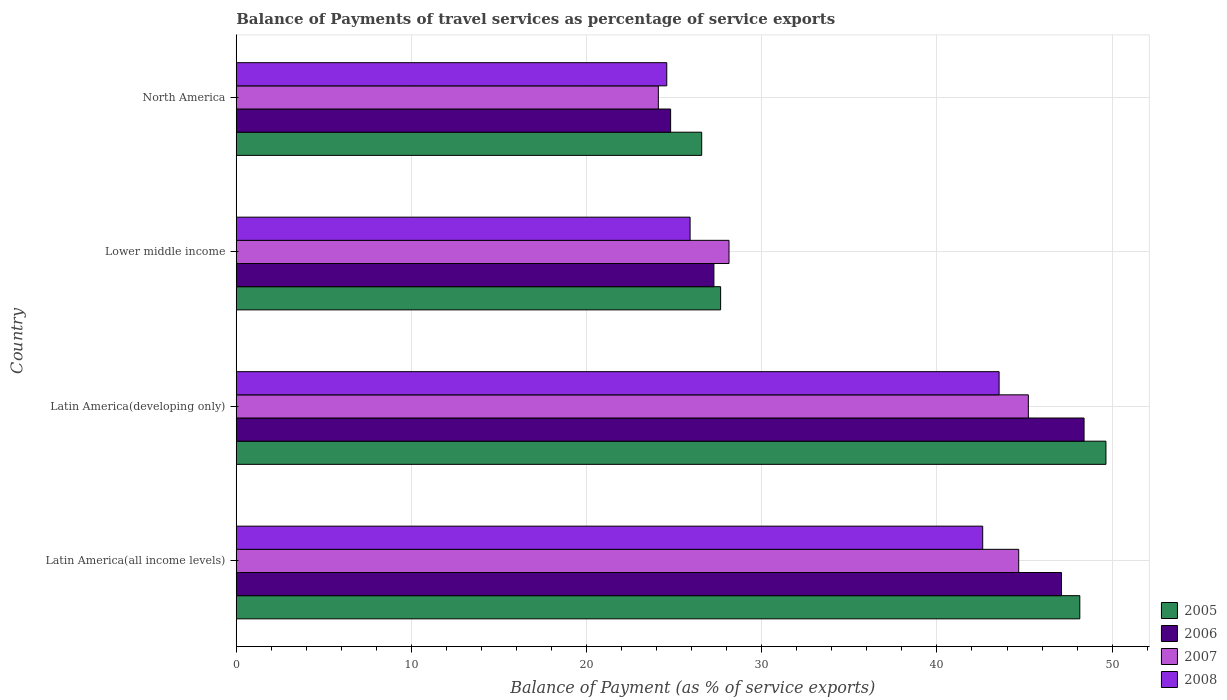How many groups of bars are there?
Offer a very short reply. 4. Are the number of bars per tick equal to the number of legend labels?
Offer a terse response. Yes. Are the number of bars on each tick of the Y-axis equal?
Ensure brevity in your answer.  Yes. How many bars are there on the 3rd tick from the top?
Your answer should be very brief. 4. How many bars are there on the 4th tick from the bottom?
Provide a short and direct response. 4. What is the label of the 3rd group of bars from the top?
Your answer should be compact. Latin America(developing only). In how many cases, is the number of bars for a given country not equal to the number of legend labels?
Ensure brevity in your answer.  0. What is the balance of payments of travel services in 2008 in Lower middle income?
Provide a succinct answer. 25.91. Across all countries, what is the maximum balance of payments of travel services in 2008?
Keep it short and to the point. 43.55. Across all countries, what is the minimum balance of payments of travel services in 2007?
Make the answer very short. 24.1. In which country was the balance of payments of travel services in 2005 maximum?
Offer a terse response. Latin America(developing only). In which country was the balance of payments of travel services in 2008 minimum?
Ensure brevity in your answer.  North America. What is the total balance of payments of travel services in 2007 in the graph?
Provide a short and direct response. 142.11. What is the difference between the balance of payments of travel services in 2007 in Latin America(all income levels) and that in Lower middle income?
Provide a succinct answer. 16.54. What is the difference between the balance of payments of travel services in 2006 in Latin America(all income levels) and the balance of payments of travel services in 2008 in Latin America(developing only)?
Ensure brevity in your answer.  3.56. What is the average balance of payments of travel services in 2005 per country?
Keep it short and to the point. 38.01. What is the difference between the balance of payments of travel services in 2008 and balance of payments of travel services in 2007 in Latin America(developing only)?
Offer a very short reply. -1.67. What is the ratio of the balance of payments of travel services in 2007 in Lower middle income to that in North America?
Offer a terse response. 1.17. Is the balance of payments of travel services in 2008 in Latin America(all income levels) less than that in Lower middle income?
Your answer should be compact. No. Is the difference between the balance of payments of travel services in 2008 in Latin America(all income levels) and North America greater than the difference between the balance of payments of travel services in 2007 in Latin America(all income levels) and North America?
Provide a short and direct response. No. What is the difference between the highest and the second highest balance of payments of travel services in 2007?
Ensure brevity in your answer.  0.55. What is the difference between the highest and the lowest balance of payments of travel services in 2006?
Ensure brevity in your answer.  23.6. Is the sum of the balance of payments of travel services in 2005 in Latin America(developing only) and Lower middle income greater than the maximum balance of payments of travel services in 2006 across all countries?
Ensure brevity in your answer.  Yes. What does the 4th bar from the bottom in Latin America(developing only) represents?
Offer a terse response. 2008. How many bars are there?
Make the answer very short. 16. Are all the bars in the graph horizontal?
Keep it short and to the point. Yes. How many countries are there in the graph?
Your answer should be very brief. 4. Are the values on the major ticks of X-axis written in scientific E-notation?
Provide a short and direct response. No. Does the graph contain grids?
Give a very brief answer. Yes. Where does the legend appear in the graph?
Your answer should be very brief. Bottom right. How many legend labels are there?
Give a very brief answer. 4. What is the title of the graph?
Provide a short and direct response. Balance of Payments of travel services as percentage of service exports. Does "1996" appear as one of the legend labels in the graph?
Ensure brevity in your answer.  No. What is the label or title of the X-axis?
Your answer should be very brief. Balance of Payment (as % of service exports). What is the Balance of Payment (as % of service exports) in 2005 in Latin America(all income levels)?
Provide a short and direct response. 48.16. What is the Balance of Payment (as % of service exports) of 2006 in Latin America(all income levels)?
Offer a terse response. 47.11. What is the Balance of Payment (as % of service exports) in 2007 in Latin America(all income levels)?
Provide a short and direct response. 44.67. What is the Balance of Payment (as % of service exports) of 2008 in Latin America(all income levels)?
Provide a short and direct response. 42.61. What is the Balance of Payment (as % of service exports) in 2005 in Latin America(developing only)?
Ensure brevity in your answer.  49.65. What is the Balance of Payment (as % of service exports) in 2006 in Latin America(developing only)?
Provide a short and direct response. 48.4. What is the Balance of Payment (as % of service exports) of 2007 in Latin America(developing only)?
Give a very brief answer. 45.22. What is the Balance of Payment (as % of service exports) in 2008 in Latin America(developing only)?
Your response must be concise. 43.55. What is the Balance of Payment (as % of service exports) in 2005 in Lower middle income?
Keep it short and to the point. 27.65. What is the Balance of Payment (as % of service exports) in 2006 in Lower middle income?
Your answer should be very brief. 27.27. What is the Balance of Payment (as % of service exports) of 2007 in Lower middle income?
Ensure brevity in your answer.  28.13. What is the Balance of Payment (as % of service exports) in 2008 in Lower middle income?
Your answer should be very brief. 25.91. What is the Balance of Payment (as % of service exports) in 2005 in North America?
Provide a short and direct response. 26.57. What is the Balance of Payment (as % of service exports) of 2006 in North America?
Your answer should be compact. 24.8. What is the Balance of Payment (as % of service exports) in 2007 in North America?
Make the answer very short. 24.1. What is the Balance of Payment (as % of service exports) in 2008 in North America?
Your answer should be compact. 24.58. Across all countries, what is the maximum Balance of Payment (as % of service exports) of 2005?
Keep it short and to the point. 49.65. Across all countries, what is the maximum Balance of Payment (as % of service exports) of 2006?
Give a very brief answer. 48.4. Across all countries, what is the maximum Balance of Payment (as % of service exports) in 2007?
Offer a terse response. 45.22. Across all countries, what is the maximum Balance of Payment (as % of service exports) in 2008?
Make the answer very short. 43.55. Across all countries, what is the minimum Balance of Payment (as % of service exports) of 2005?
Ensure brevity in your answer.  26.57. Across all countries, what is the minimum Balance of Payment (as % of service exports) of 2006?
Provide a short and direct response. 24.8. Across all countries, what is the minimum Balance of Payment (as % of service exports) of 2007?
Provide a short and direct response. 24.1. Across all countries, what is the minimum Balance of Payment (as % of service exports) in 2008?
Your answer should be compact. 24.58. What is the total Balance of Payment (as % of service exports) of 2005 in the graph?
Offer a terse response. 152.02. What is the total Balance of Payment (as % of service exports) in 2006 in the graph?
Your answer should be very brief. 147.57. What is the total Balance of Payment (as % of service exports) in 2007 in the graph?
Give a very brief answer. 142.11. What is the total Balance of Payment (as % of service exports) in 2008 in the graph?
Keep it short and to the point. 136.65. What is the difference between the Balance of Payment (as % of service exports) of 2005 in Latin America(all income levels) and that in Latin America(developing only)?
Keep it short and to the point. -1.49. What is the difference between the Balance of Payment (as % of service exports) of 2006 in Latin America(all income levels) and that in Latin America(developing only)?
Offer a terse response. -1.29. What is the difference between the Balance of Payment (as % of service exports) in 2007 in Latin America(all income levels) and that in Latin America(developing only)?
Your response must be concise. -0.55. What is the difference between the Balance of Payment (as % of service exports) of 2008 in Latin America(all income levels) and that in Latin America(developing only)?
Ensure brevity in your answer.  -0.94. What is the difference between the Balance of Payment (as % of service exports) in 2005 in Latin America(all income levels) and that in Lower middle income?
Offer a very short reply. 20.5. What is the difference between the Balance of Payment (as % of service exports) of 2006 in Latin America(all income levels) and that in Lower middle income?
Keep it short and to the point. 19.84. What is the difference between the Balance of Payment (as % of service exports) of 2007 in Latin America(all income levels) and that in Lower middle income?
Offer a terse response. 16.54. What is the difference between the Balance of Payment (as % of service exports) of 2008 in Latin America(all income levels) and that in Lower middle income?
Give a very brief answer. 16.7. What is the difference between the Balance of Payment (as % of service exports) in 2005 in Latin America(all income levels) and that in North America?
Your response must be concise. 21.59. What is the difference between the Balance of Payment (as % of service exports) in 2006 in Latin America(all income levels) and that in North America?
Your response must be concise. 22.31. What is the difference between the Balance of Payment (as % of service exports) in 2007 in Latin America(all income levels) and that in North America?
Give a very brief answer. 20.57. What is the difference between the Balance of Payment (as % of service exports) in 2008 in Latin America(all income levels) and that in North America?
Offer a very short reply. 18.04. What is the difference between the Balance of Payment (as % of service exports) of 2005 in Latin America(developing only) and that in Lower middle income?
Give a very brief answer. 22. What is the difference between the Balance of Payment (as % of service exports) in 2006 in Latin America(developing only) and that in Lower middle income?
Offer a terse response. 21.13. What is the difference between the Balance of Payment (as % of service exports) in 2007 in Latin America(developing only) and that in Lower middle income?
Your answer should be very brief. 17.09. What is the difference between the Balance of Payment (as % of service exports) in 2008 in Latin America(developing only) and that in Lower middle income?
Your response must be concise. 17.64. What is the difference between the Balance of Payment (as % of service exports) in 2005 in Latin America(developing only) and that in North America?
Provide a succinct answer. 23.08. What is the difference between the Balance of Payment (as % of service exports) in 2006 in Latin America(developing only) and that in North America?
Give a very brief answer. 23.6. What is the difference between the Balance of Payment (as % of service exports) in 2007 in Latin America(developing only) and that in North America?
Make the answer very short. 21.12. What is the difference between the Balance of Payment (as % of service exports) in 2008 in Latin America(developing only) and that in North America?
Offer a terse response. 18.97. What is the difference between the Balance of Payment (as % of service exports) of 2005 in Lower middle income and that in North America?
Your answer should be very brief. 1.08. What is the difference between the Balance of Payment (as % of service exports) of 2006 in Lower middle income and that in North America?
Your answer should be very brief. 2.47. What is the difference between the Balance of Payment (as % of service exports) of 2007 in Lower middle income and that in North America?
Offer a terse response. 4.03. What is the difference between the Balance of Payment (as % of service exports) of 2008 in Lower middle income and that in North America?
Your response must be concise. 1.33. What is the difference between the Balance of Payment (as % of service exports) of 2005 in Latin America(all income levels) and the Balance of Payment (as % of service exports) of 2006 in Latin America(developing only)?
Ensure brevity in your answer.  -0.24. What is the difference between the Balance of Payment (as % of service exports) in 2005 in Latin America(all income levels) and the Balance of Payment (as % of service exports) in 2007 in Latin America(developing only)?
Your answer should be very brief. 2.94. What is the difference between the Balance of Payment (as % of service exports) of 2005 in Latin America(all income levels) and the Balance of Payment (as % of service exports) of 2008 in Latin America(developing only)?
Your answer should be very brief. 4.61. What is the difference between the Balance of Payment (as % of service exports) in 2006 in Latin America(all income levels) and the Balance of Payment (as % of service exports) in 2007 in Latin America(developing only)?
Provide a short and direct response. 1.89. What is the difference between the Balance of Payment (as % of service exports) in 2006 in Latin America(all income levels) and the Balance of Payment (as % of service exports) in 2008 in Latin America(developing only)?
Offer a terse response. 3.56. What is the difference between the Balance of Payment (as % of service exports) in 2007 in Latin America(all income levels) and the Balance of Payment (as % of service exports) in 2008 in Latin America(developing only)?
Offer a terse response. 1.12. What is the difference between the Balance of Payment (as % of service exports) in 2005 in Latin America(all income levels) and the Balance of Payment (as % of service exports) in 2006 in Lower middle income?
Offer a very short reply. 20.89. What is the difference between the Balance of Payment (as % of service exports) of 2005 in Latin America(all income levels) and the Balance of Payment (as % of service exports) of 2007 in Lower middle income?
Offer a terse response. 20.03. What is the difference between the Balance of Payment (as % of service exports) of 2005 in Latin America(all income levels) and the Balance of Payment (as % of service exports) of 2008 in Lower middle income?
Provide a succinct answer. 22.25. What is the difference between the Balance of Payment (as % of service exports) in 2006 in Latin America(all income levels) and the Balance of Payment (as % of service exports) in 2007 in Lower middle income?
Your answer should be very brief. 18.98. What is the difference between the Balance of Payment (as % of service exports) in 2006 in Latin America(all income levels) and the Balance of Payment (as % of service exports) in 2008 in Lower middle income?
Give a very brief answer. 21.2. What is the difference between the Balance of Payment (as % of service exports) in 2007 in Latin America(all income levels) and the Balance of Payment (as % of service exports) in 2008 in Lower middle income?
Give a very brief answer. 18.76. What is the difference between the Balance of Payment (as % of service exports) of 2005 in Latin America(all income levels) and the Balance of Payment (as % of service exports) of 2006 in North America?
Provide a short and direct response. 23.36. What is the difference between the Balance of Payment (as % of service exports) of 2005 in Latin America(all income levels) and the Balance of Payment (as % of service exports) of 2007 in North America?
Offer a very short reply. 24.06. What is the difference between the Balance of Payment (as % of service exports) of 2005 in Latin America(all income levels) and the Balance of Payment (as % of service exports) of 2008 in North America?
Give a very brief answer. 23.58. What is the difference between the Balance of Payment (as % of service exports) of 2006 in Latin America(all income levels) and the Balance of Payment (as % of service exports) of 2007 in North America?
Make the answer very short. 23.01. What is the difference between the Balance of Payment (as % of service exports) in 2006 in Latin America(all income levels) and the Balance of Payment (as % of service exports) in 2008 in North America?
Offer a very short reply. 22.53. What is the difference between the Balance of Payment (as % of service exports) in 2007 in Latin America(all income levels) and the Balance of Payment (as % of service exports) in 2008 in North America?
Ensure brevity in your answer.  20.09. What is the difference between the Balance of Payment (as % of service exports) of 2005 in Latin America(developing only) and the Balance of Payment (as % of service exports) of 2006 in Lower middle income?
Offer a terse response. 22.38. What is the difference between the Balance of Payment (as % of service exports) in 2005 in Latin America(developing only) and the Balance of Payment (as % of service exports) in 2007 in Lower middle income?
Your answer should be compact. 21.52. What is the difference between the Balance of Payment (as % of service exports) of 2005 in Latin America(developing only) and the Balance of Payment (as % of service exports) of 2008 in Lower middle income?
Your answer should be very brief. 23.74. What is the difference between the Balance of Payment (as % of service exports) of 2006 in Latin America(developing only) and the Balance of Payment (as % of service exports) of 2007 in Lower middle income?
Offer a very short reply. 20.27. What is the difference between the Balance of Payment (as % of service exports) of 2006 in Latin America(developing only) and the Balance of Payment (as % of service exports) of 2008 in Lower middle income?
Offer a very short reply. 22.49. What is the difference between the Balance of Payment (as % of service exports) in 2007 in Latin America(developing only) and the Balance of Payment (as % of service exports) in 2008 in Lower middle income?
Keep it short and to the point. 19.31. What is the difference between the Balance of Payment (as % of service exports) in 2005 in Latin America(developing only) and the Balance of Payment (as % of service exports) in 2006 in North America?
Make the answer very short. 24.85. What is the difference between the Balance of Payment (as % of service exports) of 2005 in Latin America(developing only) and the Balance of Payment (as % of service exports) of 2007 in North America?
Offer a very short reply. 25.55. What is the difference between the Balance of Payment (as % of service exports) of 2005 in Latin America(developing only) and the Balance of Payment (as % of service exports) of 2008 in North America?
Offer a terse response. 25.07. What is the difference between the Balance of Payment (as % of service exports) of 2006 in Latin America(developing only) and the Balance of Payment (as % of service exports) of 2007 in North America?
Provide a short and direct response. 24.3. What is the difference between the Balance of Payment (as % of service exports) in 2006 in Latin America(developing only) and the Balance of Payment (as % of service exports) in 2008 in North America?
Provide a succinct answer. 23.82. What is the difference between the Balance of Payment (as % of service exports) of 2007 in Latin America(developing only) and the Balance of Payment (as % of service exports) of 2008 in North America?
Your answer should be very brief. 20.64. What is the difference between the Balance of Payment (as % of service exports) of 2005 in Lower middle income and the Balance of Payment (as % of service exports) of 2006 in North America?
Your answer should be compact. 2.85. What is the difference between the Balance of Payment (as % of service exports) in 2005 in Lower middle income and the Balance of Payment (as % of service exports) in 2007 in North America?
Your answer should be very brief. 3.56. What is the difference between the Balance of Payment (as % of service exports) of 2005 in Lower middle income and the Balance of Payment (as % of service exports) of 2008 in North America?
Keep it short and to the point. 3.07. What is the difference between the Balance of Payment (as % of service exports) in 2006 in Lower middle income and the Balance of Payment (as % of service exports) in 2007 in North America?
Offer a terse response. 3.17. What is the difference between the Balance of Payment (as % of service exports) in 2006 in Lower middle income and the Balance of Payment (as % of service exports) in 2008 in North America?
Offer a very short reply. 2.69. What is the difference between the Balance of Payment (as % of service exports) in 2007 in Lower middle income and the Balance of Payment (as % of service exports) in 2008 in North America?
Ensure brevity in your answer.  3.55. What is the average Balance of Payment (as % of service exports) of 2005 per country?
Make the answer very short. 38.01. What is the average Balance of Payment (as % of service exports) in 2006 per country?
Ensure brevity in your answer.  36.89. What is the average Balance of Payment (as % of service exports) of 2007 per country?
Make the answer very short. 35.53. What is the average Balance of Payment (as % of service exports) in 2008 per country?
Give a very brief answer. 34.16. What is the difference between the Balance of Payment (as % of service exports) in 2005 and Balance of Payment (as % of service exports) in 2006 in Latin America(all income levels)?
Keep it short and to the point. 1.05. What is the difference between the Balance of Payment (as % of service exports) in 2005 and Balance of Payment (as % of service exports) in 2007 in Latin America(all income levels)?
Give a very brief answer. 3.49. What is the difference between the Balance of Payment (as % of service exports) in 2005 and Balance of Payment (as % of service exports) in 2008 in Latin America(all income levels)?
Your answer should be very brief. 5.54. What is the difference between the Balance of Payment (as % of service exports) in 2006 and Balance of Payment (as % of service exports) in 2007 in Latin America(all income levels)?
Your response must be concise. 2.44. What is the difference between the Balance of Payment (as % of service exports) of 2006 and Balance of Payment (as % of service exports) of 2008 in Latin America(all income levels)?
Provide a succinct answer. 4.5. What is the difference between the Balance of Payment (as % of service exports) in 2007 and Balance of Payment (as % of service exports) in 2008 in Latin America(all income levels)?
Your answer should be compact. 2.05. What is the difference between the Balance of Payment (as % of service exports) in 2005 and Balance of Payment (as % of service exports) in 2006 in Latin America(developing only)?
Offer a very short reply. 1.25. What is the difference between the Balance of Payment (as % of service exports) of 2005 and Balance of Payment (as % of service exports) of 2007 in Latin America(developing only)?
Make the answer very short. 4.43. What is the difference between the Balance of Payment (as % of service exports) of 2005 and Balance of Payment (as % of service exports) of 2008 in Latin America(developing only)?
Your answer should be compact. 6.1. What is the difference between the Balance of Payment (as % of service exports) of 2006 and Balance of Payment (as % of service exports) of 2007 in Latin America(developing only)?
Keep it short and to the point. 3.18. What is the difference between the Balance of Payment (as % of service exports) in 2006 and Balance of Payment (as % of service exports) in 2008 in Latin America(developing only)?
Your response must be concise. 4.85. What is the difference between the Balance of Payment (as % of service exports) in 2007 and Balance of Payment (as % of service exports) in 2008 in Latin America(developing only)?
Offer a terse response. 1.67. What is the difference between the Balance of Payment (as % of service exports) in 2005 and Balance of Payment (as % of service exports) in 2006 in Lower middle income?
Provide a succinct answer. 0.38. What is the difference between the Balance of Payment (as % of service exports) in 2005 and Balance of Payment (as % of service exports) in 2007 in Lower middle income?
Offer a terse response. -0.48. What is the difference between the Balance of Payment (as % of service exports) of 2005 and Balance of Payment (as % of service exports) of 2008 in Lower middle income?
Offer a terse response. 1.74. What is the difference between the Balance of Payment (as % of service exports) of 2006 and Balance of Payment (as % of service exports) of 2007 in Lower middle income?
Your answer should be compact. -0.86. What is the difference between the Balance of Payment (as % of service exports) in 2006 and Balance of Payment (as % of service exports) in 2008 in Lower middle income?
Keep it short and to the point. 1.36. What is the difference between the Balance of Payment (as % of service exports) in 2007 and Balance of Payment (as % of service exports) in 2008 in Lower middle income?
Your answer should be compact. 2.22. What is the difference between the Balance of Payment (as % of service exports) of 2005 and Balance of Payment (as % of service exports) of 2006 in North America?
Keep it short and to the point. 1.77. What is the difference between the Balance of Payment (as % of service exports) in 2005 and Balance of Payment (as % of service exports) in 2007 in North America?
Give a very brief answer. 2.47. What is the difference between the Balance of Payment (as % of service exports) of 2005 and Balance of Payment (as % of service exports) of 2008 in North America?
Give a very brief answer. 1.99. What is the difference between the Balance of Payment (as % of service exports) in 2006 and Balance of Payment (as % of service exports) in 2007 in North America?
Ensure brevity in your answer.  0.7. What is the difference between the Balance of Payment (as % of service exports) of 2006 and Balance of Payment (as % of service exports) of 2008 in North America?
Ensure brevity in your answer.  0.22. What is the difference between the Balance of Payment (as % of service exports) of 2007 and Balance of Payment (as % of service exports) of 2008 in North America?
Your response must be concise. -0.48. What is the ratio of the Balance of Payment (as % of service exports) of 2006 in Latin America(all income levels) to that in Latin America(developing only)?
Your answer should be compact. 0.97. What is the ratio of the Balance of Payment (as % of service exports) in 2007 in Latin America(all income levels) to that in Latin America(developing only)?
Give a very brief answer. 0.99. What is the ratio of the Balance of Payment (as % of service exports) of 2008 in Latin America(all income levels) to that in Latin America(developing only)?
Your answer should be compact. 0.98. What is the ratio of the Balance of Payment (as % of service exports) of 2005 in Latin America(all income levels) to that in Lower middle income?
Your response must be concise. 1.74. What is the ratio of the Balance of Payment (as % of service exports) in 2006 in Latin America(all income levels) to that in Lower middle income?
Offer a very short reply. 1.73. What is the ratio of the Balance of Payment (as % of service exports) of 2007 in Latin America(all income levels) to that in Lower middle income?
Make the answer very short. 1.59. What is the ratio of the Balance of Payment (as % of service exports) in 2008 in Latin America(all income levels) to that in Lower middle income?
Keep it short and to the point. 1.64. What is the ratio of the Balance of Payment (as % of service exports) of 2005 in Latin America(all income levels) to that in North America?
Offer a very short reply. 1.81. What is the ratio of the Balance of Payment (as % of service exports) in 2006 in Latin America(all income levels) to that in North America?
Make the answer very short. 1.9. What is the ratio of the Balance of Payment (as % of service exports) in 2007 in Latin America(all income levels) to that in North America?
Give a very brief answer. 1.85. What is the ratio of the Balance of Payment (as % of service exports) of 2008 in Latin America(all income levels) to that in North America?
Ensure brevity in your answer.  1.73. What is the ratio of the Balance of Payment (as % of service exports) of 2005 in Latin America(developing only) to that in Lower middle income?
Offer a terse response. 1.8. What is the ratio of the Balance of Payment (as % of service exports) of 2006 in Latin America(developing only) to that in Lower middle income?
Provide a short and direct response. 1.77. What is the ratio of the Balance of Payment (as % of service exports) in 2007 in Latin America(developing only) to that in Lower middle income?
Make the answer very short. 1.61. What is the ratio of the Balance of Payment (as % of service exports) in 2008 in Latin America(developing only) to that in Lower middle income?
Offer a very short reply. 1.68. What is the ratio of the Balance of Payment (as % of service exports) of 2005 in Latin America(developing only) to that in North America?
Provide a succinct answer. 1.87. What is the ratio of the Balance of Payment (as % of service exports) in 2006 in Latin America(developing only) to that in North America?
Give a very brief answer. 1.95. What is the ratio of the Balance of Payment (as % of service exports) in 2007 in Latin America(developing only) to that in North America?
Provide a succinct answer. 1.88. What is the ratio of the Balance of Payment (as % of service exports) in 2008 in Latin America(developing only) to that in North America?
Your response must be concise. 1.77. What is the ratio of the Balance of Payment (as % of service exports) of 2005 in Lower middle income to that in North America?
Ensure brevity in your answer.  1.04. What is the ratio of the Balance of Payment (as % of service exports) in 2006 in Lower middle income to that in North America?
Provide a short and direct response. 1.1. What is the ratio of the Balance of Payment (as % of service exports) in 2007 in Lower middle income to that in North America?
Your answer should be very brief. 1.17. What is the ratio of the Balance of Payment (as % of service exports) in 2008 in Lower middle income to that in North America?
Give a very brief answer. 1.05. What is the difference between the highest and the second highest Balance of Payment (as % of service exports) in 2005?
Your response must be concise. 1.49. What is the difference between the highest and the second highest Balance of Payment (as % of service exports) in 2006?
Make the answer very short. 1.29. What is the difference between the highest and the second highest Balance of Payment (as % of service exports) of 2007?
Your response must be concise. 0.55. What is the difference between the highest and the second highest Balance of Payment (as % of service exports) of 2008?
Your answer should be compact. 0.94. What is the difference between the highest and the lowest Balance of Payment (as % of service exports) in 2005?
Offer a very short reply. 23.08. What is the difference between the highest and the lowest Balance of Payment (as % of service exports) in 2006?
Offer a very short reply. 23.6. What is the difference between the highest and the lowest Balance of Payment (as % of service exports) in 2007?
Keep it short and to the point. 21.12. What is the difference between the highest and the lowest Balance of Payment (as % of service exports) in 2008?
Offer a very short reply. 18.97. 